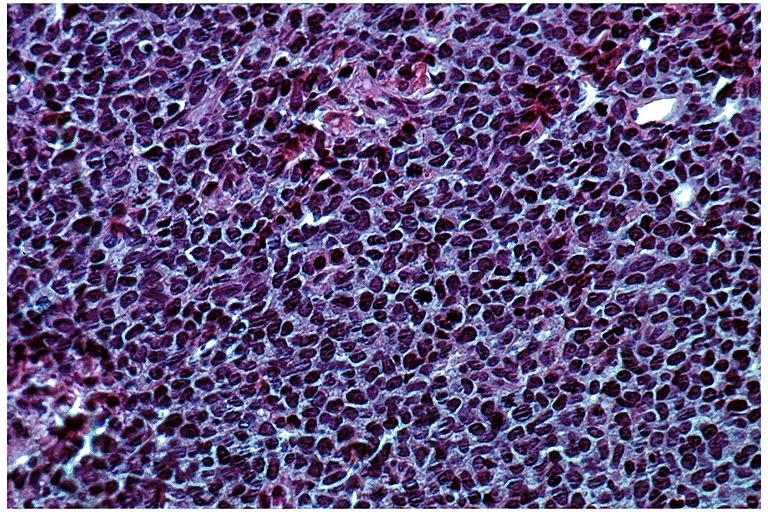does excellent vertebral body primary show lymphoma?
Answer the question using a single word or phrase. No 